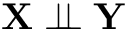Convert formula to latex. <formula><loc_0><loc_0><loc_500><loc_500>X \perp \, \perp Y</formula> 